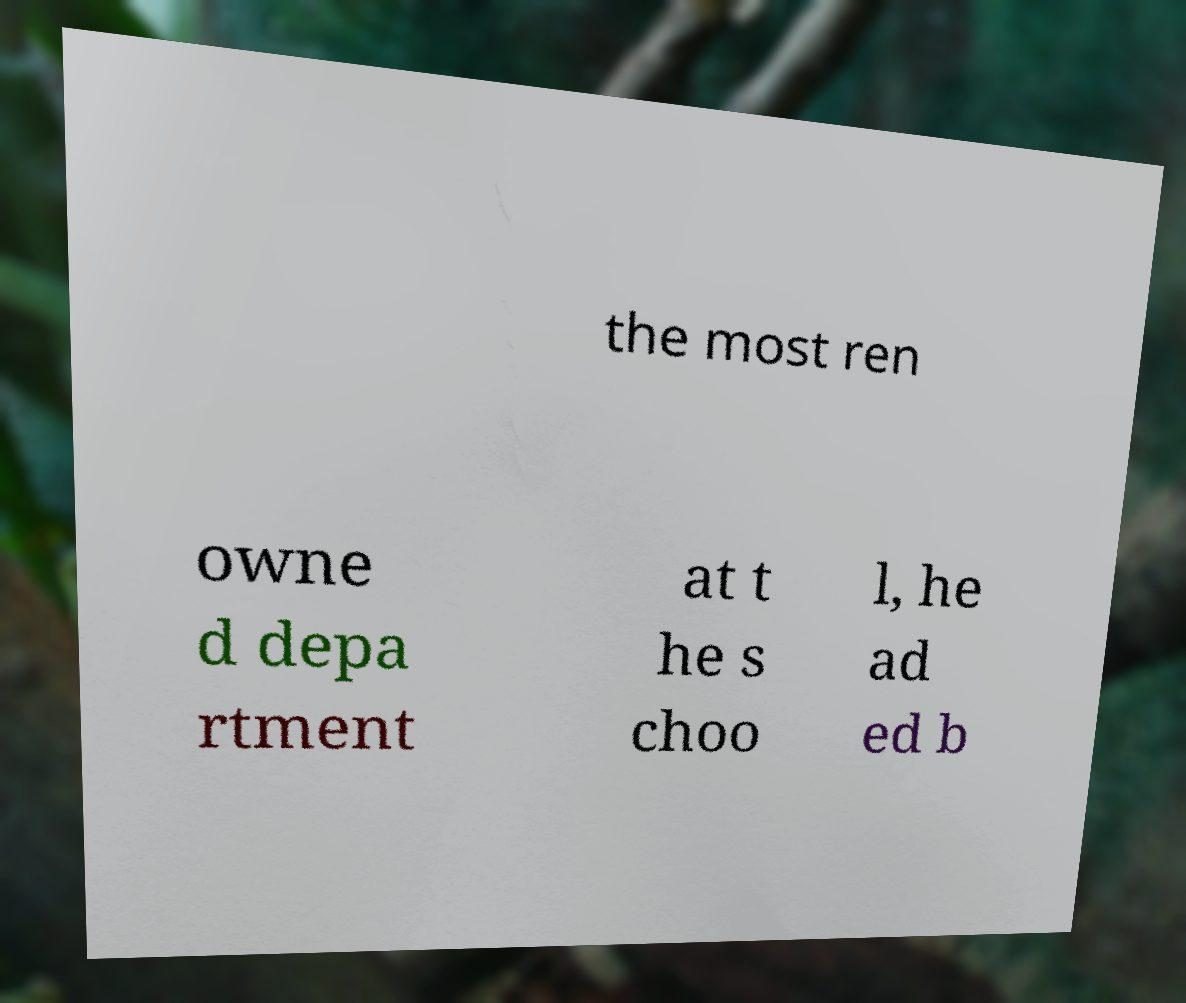What messages or text are displayed in this image? I need them in a readable, typed format. the most ren owne d depa rtment at t he s choo l, he ad ed b 